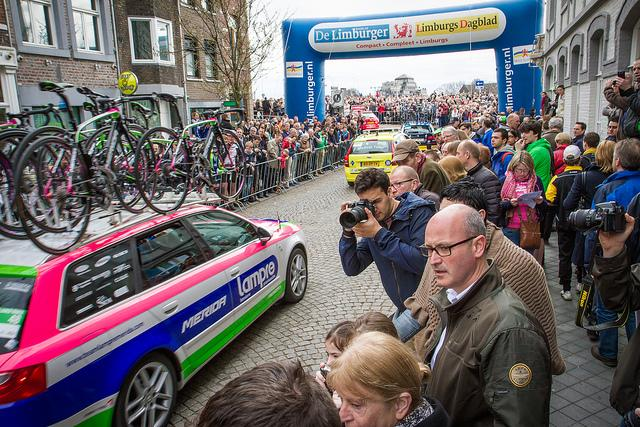What will the man in the blue sweatshirt do next? Please explain your reasoning. take photograph. The man is taking a photo. 